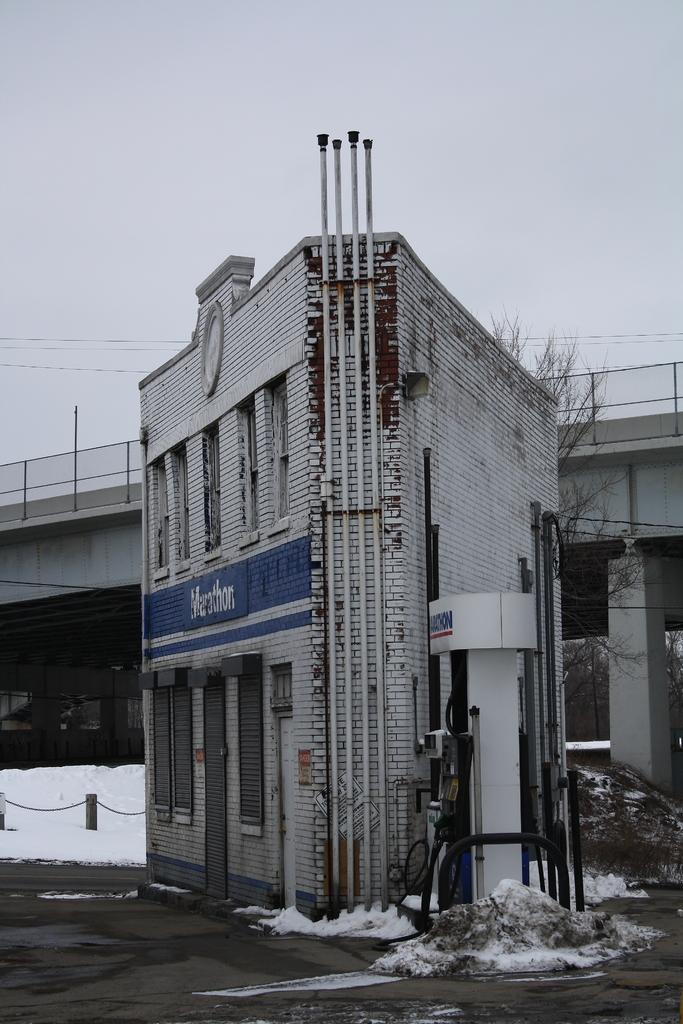What type of structure is present in the image? There is a building in the image. What features can be seen on the building? The building has windows, a door, and pipes. What is visible in the background of the image? There is snow and a bridge with pillars in the background of the image. What type of vegetation is present in the image? There is a tree in the image. What part of the natural environment is visible in the image? The sky is visible in the background of the image. What type of pump can be seen in the image? There is no pump present in the image. How many friends are visible in the image? There are no people, including friends, present in the image. 